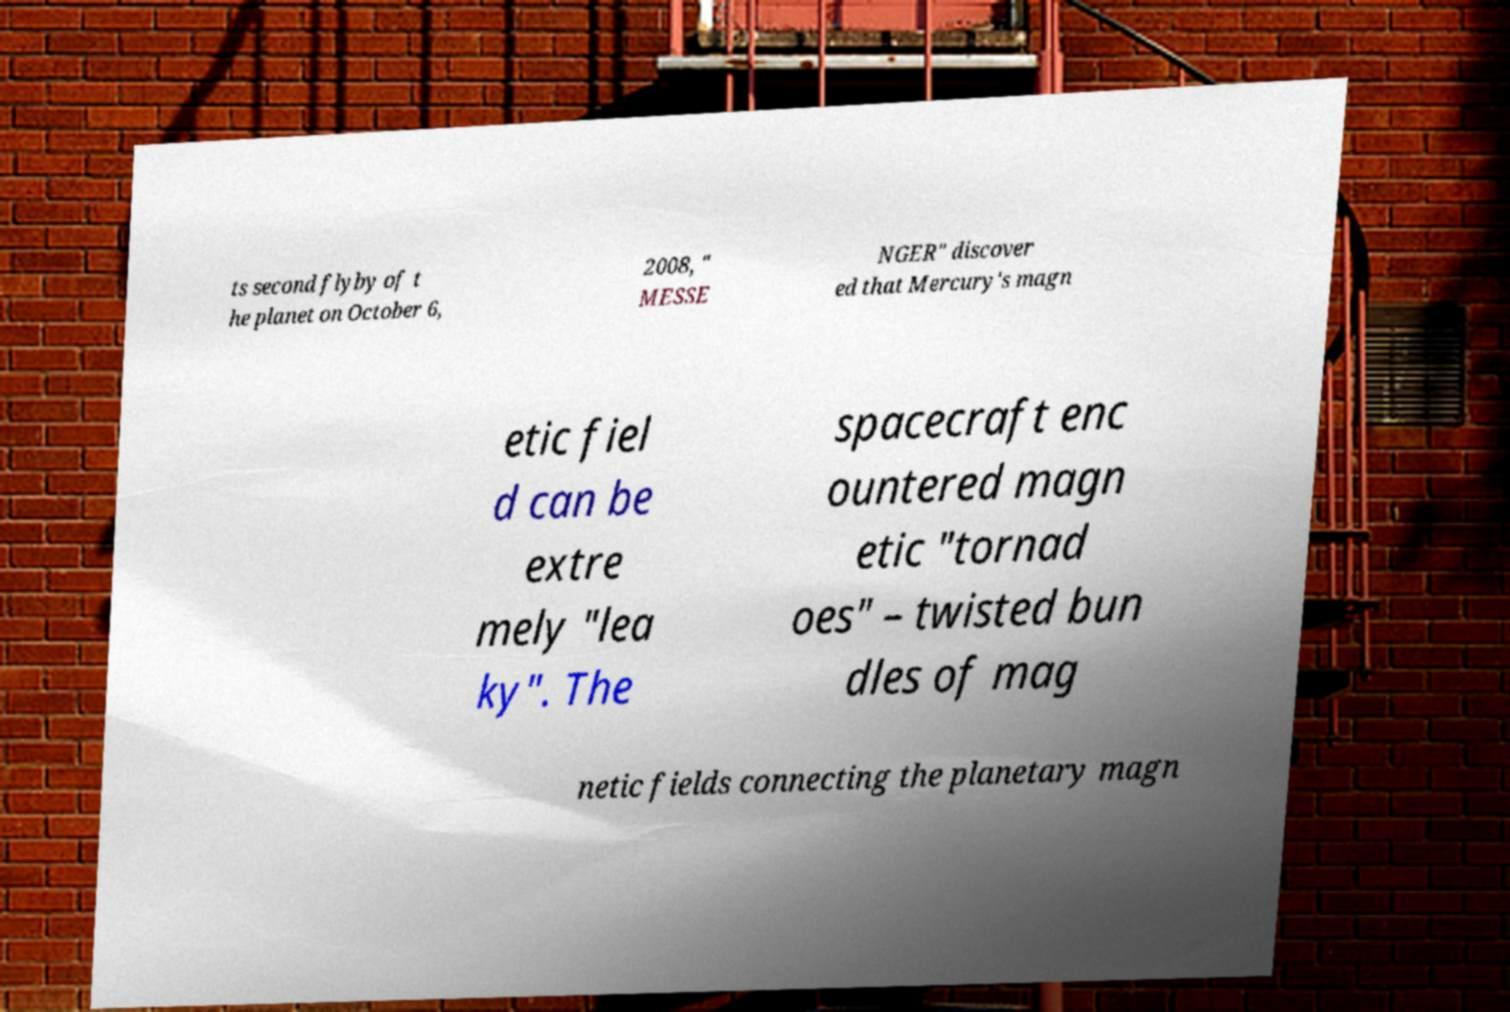Please identify and transcribe the text found in this image. ts second flyby of t he planet on October 6, 2008, " MESSE NGER" discover ed that Mercury's magn etic fiel d can be extre mely "lea ky". The spacecraft enc ountered magn etic "tornad oes" – twisted bun dles of mag netic fields connecting the planetary magn 